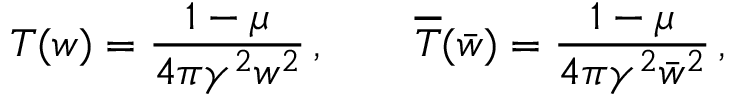Convert formula to latex. <formula><loc_0><loc_0><loc_500><loc_500>T ( w ) = \frac { 1 - \mu } { 4 \pi \gamma ^ { 2 } w ^ { 2 } } \, , \quad \overline { T } ( \bar { w } ) = \frac { 1 - \mu } { 4 \pi \gamma ^ { 2 } \bar { w } ^ { 2 } } \, ,</formula> 